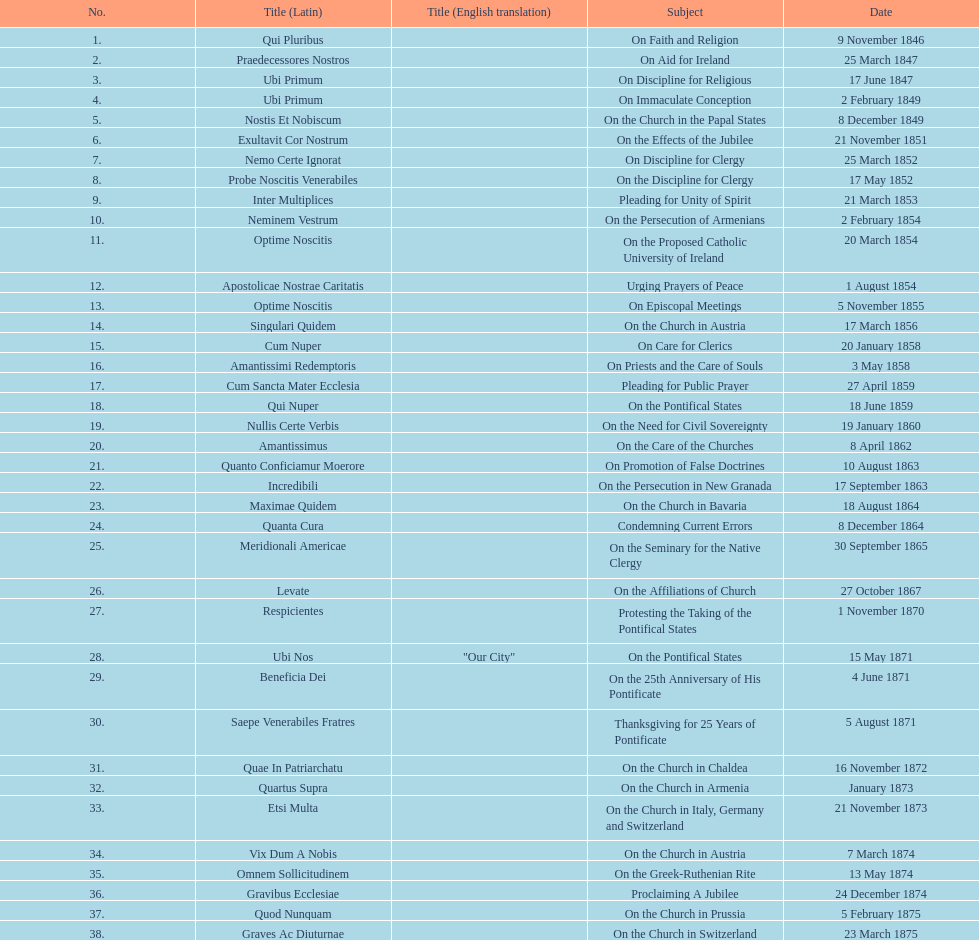How many areas of study are there? 38. 